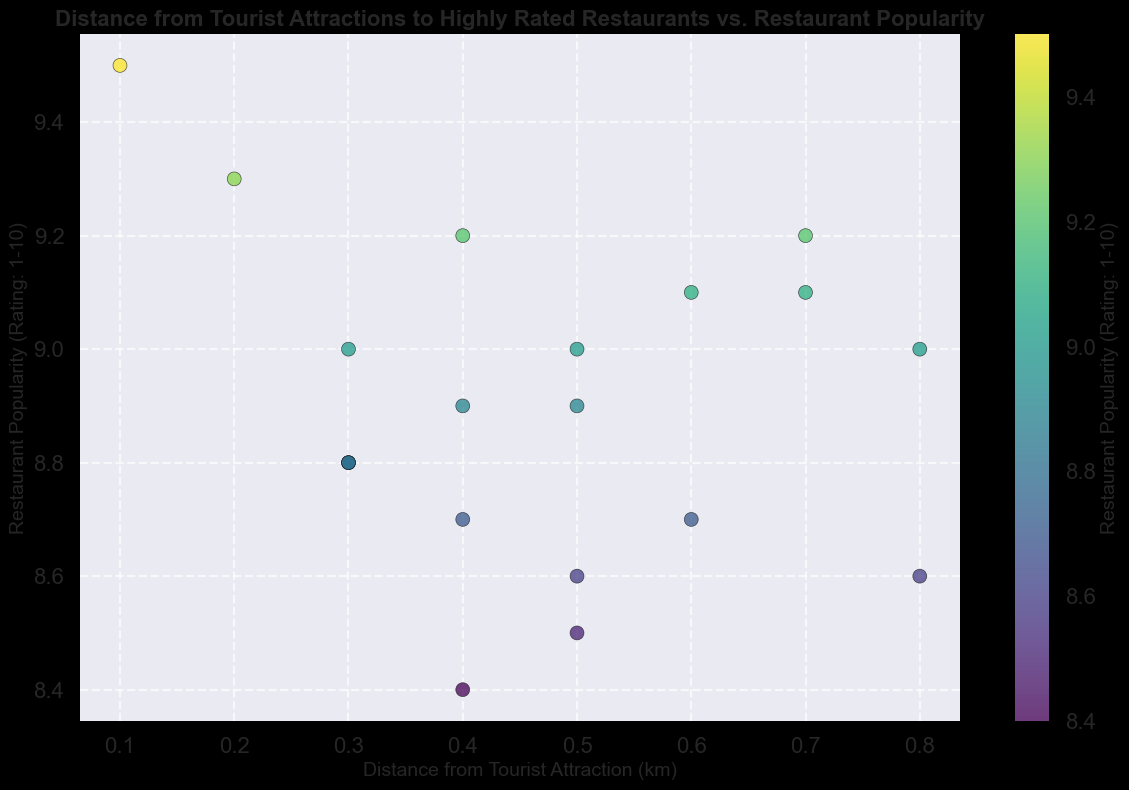Which restaurant is closest to a tourist attraction? By looking at the figure, find the point with the smallest distance value on the x-axis, which represents the shortest distance.
Answer: Myeongdong Kyoja What is the maximum popularity rating in the plot? Identify the highest value on the y-axis, which corresponds to the popularity rating.
Answer: 9.5 Compare Baeknyeon Tojong Samgyetang and Tosokchon Samgyetang in terms of distance from Gyeongbokgung Palace. Which one is closer? Locate the points corresponding to these restaurants. Baeknyeon Tojong Samgyetang has a distance of 0.5 km, whereas Tosokchon Samgyetang has a distance of 0.7 km.
Answer: Baeknyeon Tojong Samgyetang How many restaurants have a popularity rating of 9.0 or higher? Count all points on the figure with y-values of 9.0 or higher.
Answer: 9 What is the average distance from the tourist attractions for restaurants with a popularity rating above 9.0? Identify points with y-values above 9.0, sum their x-values, and divide by the number of these points. The distances are: 0.7, 0.6, 0.2, 0.1, 0.8, 0.3, 0.3, 0.3, 0.4. Sum = 3.7 km, number of points = 9. Average distance = 3.7/9.
Answer: 0.41 km Which tourist attraction has the largest spread of restaurant distances? By observing the width of the scatter plot horizontally for each tourist attraction and identifying the one with the widest spread.
Answer: Changdeokgung Palace Identify the tourist attraction associated with the highest-rated restaurant. Find the point with the highest y-value and examine the corresponding label or legend in the figure.
Answer: Myeongdong Cathedral What is the difference in popularity between the highest and lowest rated restaurants? Identify the highest y-value (9.5) and the lowest y-value (8.4). The difference is 9.5 - 8.4.
Answer: 1.1 Compare the distances of Cafe Bora and Suwan Daegukbap from Bukchon Hanok Village. Which is farther? Locate both points in the figure; Cafe Bora is at 0.4 km and Suwan Daegukbap is at 0.6 km.
Answer: Suwan Daegukbap 